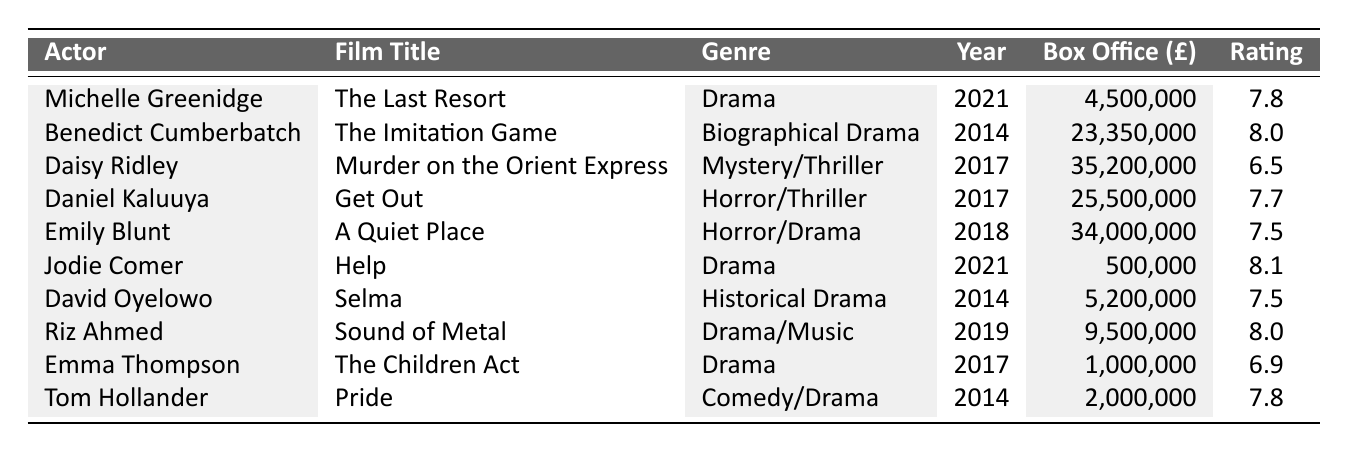What is the box office earnings of "The Last Resort"? From the table, we can see that the box office earnings for "The Last Resort", featuring Michelle Greenidge, are listed as £4,500,000.
Answer: £4,500,000 Which film has the highest rating? By looking at the ratings in the table, we identify that "Help" starring Jodie Comer has the highest rating of 8.1.
Answer: 8.1 What genre does "Get Out" belong to? According to the table, "Get Out" is classified under the genre of Horror/Thriller.
Answer: Horror/Thriller How many films listed were released in 2014? The table shows three films released in 2014: "The Imitation Game", "Selma", and "Pride", totaling three films.
Answer: 3 What is the average box office earnings of the films listed? Adding up all the box office earnings (£4,500,000 + £23,350,000 + £35,200,000 + £25,500,000 + £34,000,000 + £500,000 + £5,200,000 + £9,500,000 + £1,000,000 + £2,000,000) equals £140,100,000, and dividing by the total number of films (10) gives an average of £14,010,000.
Answer: £14,010,000 Did any film have a box office earning less than £1 million? Referring to the table, "Help" has box office earnings of £500,000 which is less than £1 million, confirming that yes, there is a film below this threshold.
Answer: Yes Which actor's film has the lowest box office earnings? From the table, "Help" featuring Jodie Comer has the lowest box office earnings of £500,000, making her the actor with the lowest earnings related to their film.
Answer: Jodie Comer If we consider only the Drama category, what is the average rating of these films? The Drama films listed are "The Last Resort", "Help", "The Children Act" (each with ratings of 7.8, 8.1, and 6.9 respectively). Therefore, the average rating is (7.8 + 8.1 + 6.9) / 3 = 7.63.
Answer: 7.63 What is the difference in box office earnings between "A Quiet Place" and "Get Out"? "A Quiet Place" has box office earnings of £34,000,000 and "Get Out" has £25,500,000. The difference in earnings is £34,000,000 - £25,500,000 = £8,500,000.
Answer: £8,500,000 Is there any film in the table that has a lower rating than 7.0? By examining the ratings, "Murder on the Orient Express" has a rating of 6.5, which is indeed lower than 7.0, confirming there is such a film.
Answer: Yes 